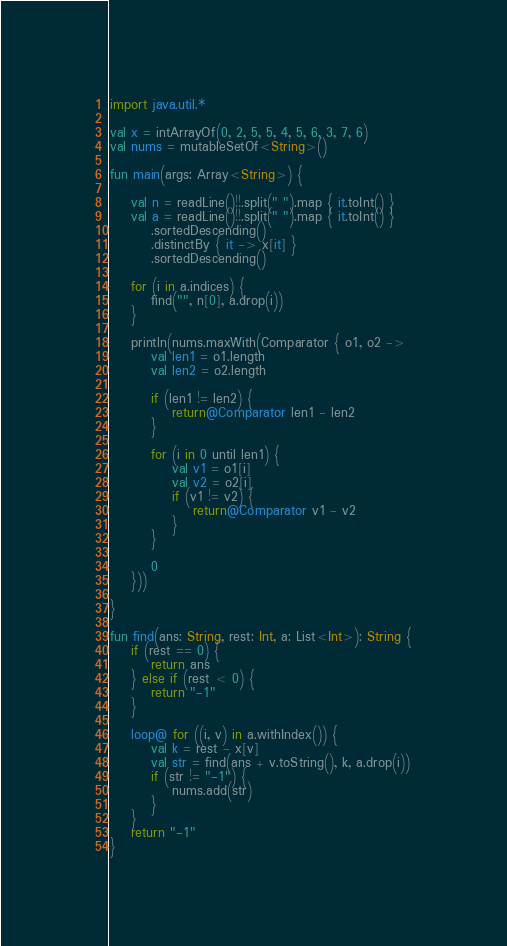Convert code to text. <code><loc_0><loc_0><loc_500><loc_500><_Kotlin_>import java.util.*

val x = intArrayOf(0, 2, 5, 5, 4, 5, 6, 3, 7, 6)
val nums = mutableSetOf<String>()

fun main(args: Array<String>) {

    val n = readLine()!!.split(" ").map { it.toInt() }
    val a = readLine()!!.split(" ").map { it.toInt() }
        .sortedDescending()
        .distinctBy { it -> x[it] }
        .sortedDescending()

    for (i in a.indices) {
        find("", n[0], a.drop(i))
    }
    
    println(nums.maxWith(Comparator { o1, o2 ->
        val len1 = o1.length
        val len2 = o2.length

        if (len1 != len2) {
            return@Comparator len1 - len2
        }

        for (i in 0 until len1) {
            val v1 = o1[i]
            val v2 = o2[i]
            if (v1 != v2) {
                return@Comparator v1 - v2
            }
        }

        0
    }))

}

fun find(ans: String, rest: Int, a: List<Int>): String {
    if (rest == 0) {
        return ans
    } else if (rest < 0) {
        return "-1"
    }

    loop@ for ((i, v) in a.withIndex()) {
        val k = rest - x[v]
        val str = find(ans + v.toString(), k, a.drop(i))
        if (str != "-1") {
            nums.add(str)
        }
    }
    return "-1"
}</code> 